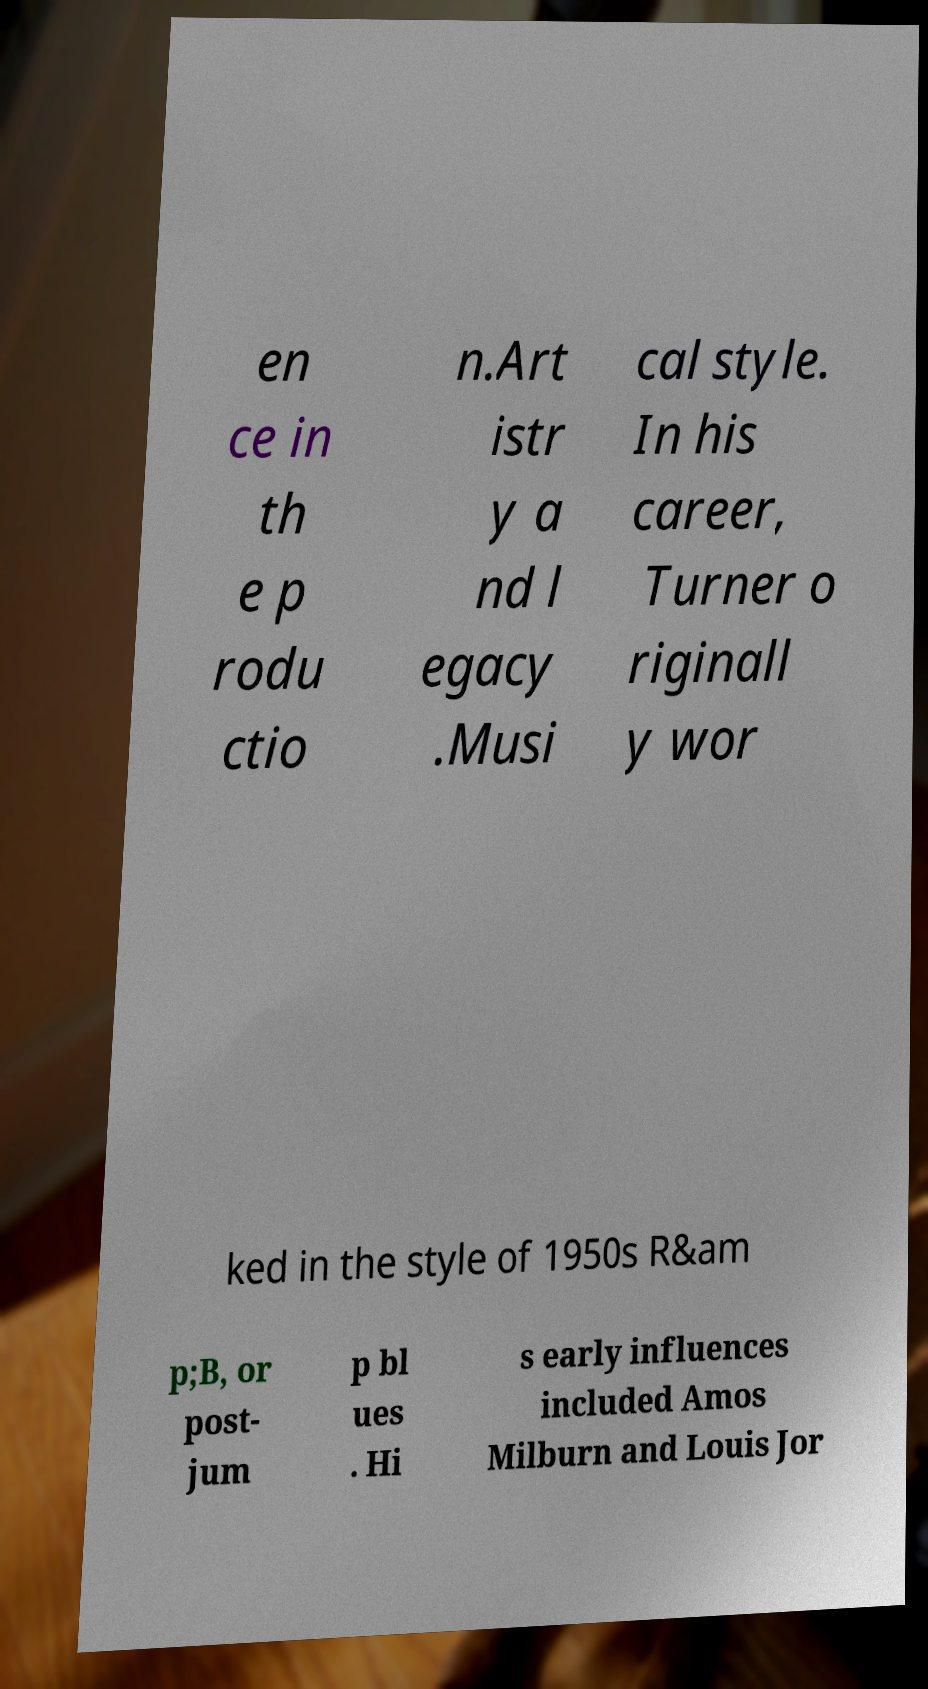Please identify and transcribe the text found in this image. en ce in th e p rodu ctio n.Art istr y a nd l egacy .Musi cal style. In his career, Turner o riginall y wor ked in the style of 1950s R&am p;B, or post- jum p bl ues . Hi s early influences included Amos Milburn and Louis Jor 